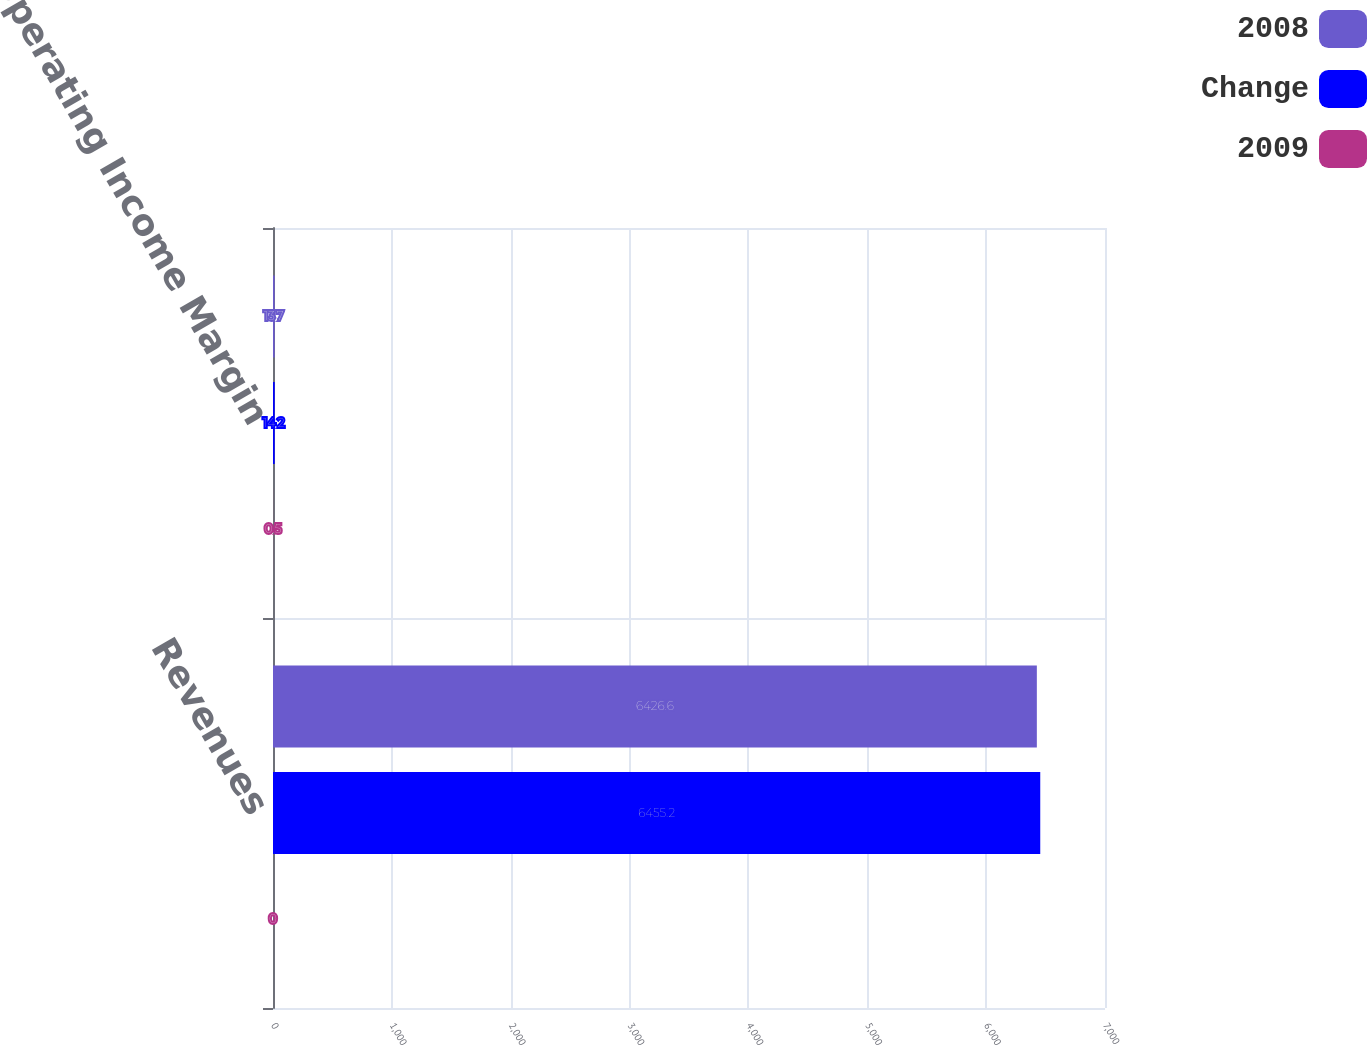<chart> <loc_0><loc_0><loc_500><loc_500><stacked_bar_chart><ecel><fcel>Revenues<fcel>Operating Income Margin<nl><fcel>2008<fcel>6426.6<fcel>13.7<nl><fcel>Change<fcel>6455.2<fcel>14.2<nl><fcel>2009<fcel>0<fcel>0.5<nl></chart> 